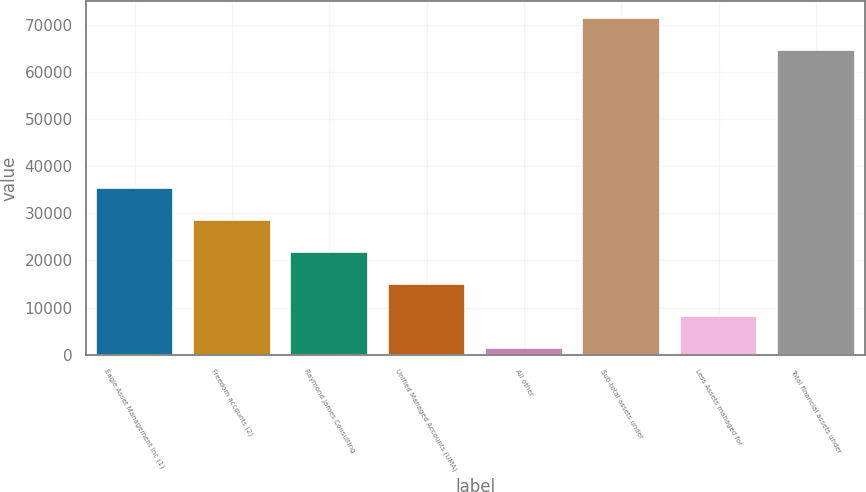<chart> <loc_0><loc_0><loc_500><loc_500><bar_chart><fcel>Eagle Asset Management Inc (1)<fcel>Freedom accounts (2)<fcel>Raymond James Consulting<fcel>Unified Managed Accounts (UMA)<fcel>All other<fcel>Sub-total assets under<fcel>Less Assets managed for<fcel>Total financial assets under<nl><fcel>35375<fcel>28576.4<fcel>21777.8<fcel>14979.2<fcel>1382<fcel>71355.6<fcel>8180.6<fcel>64557<nl></chart> 